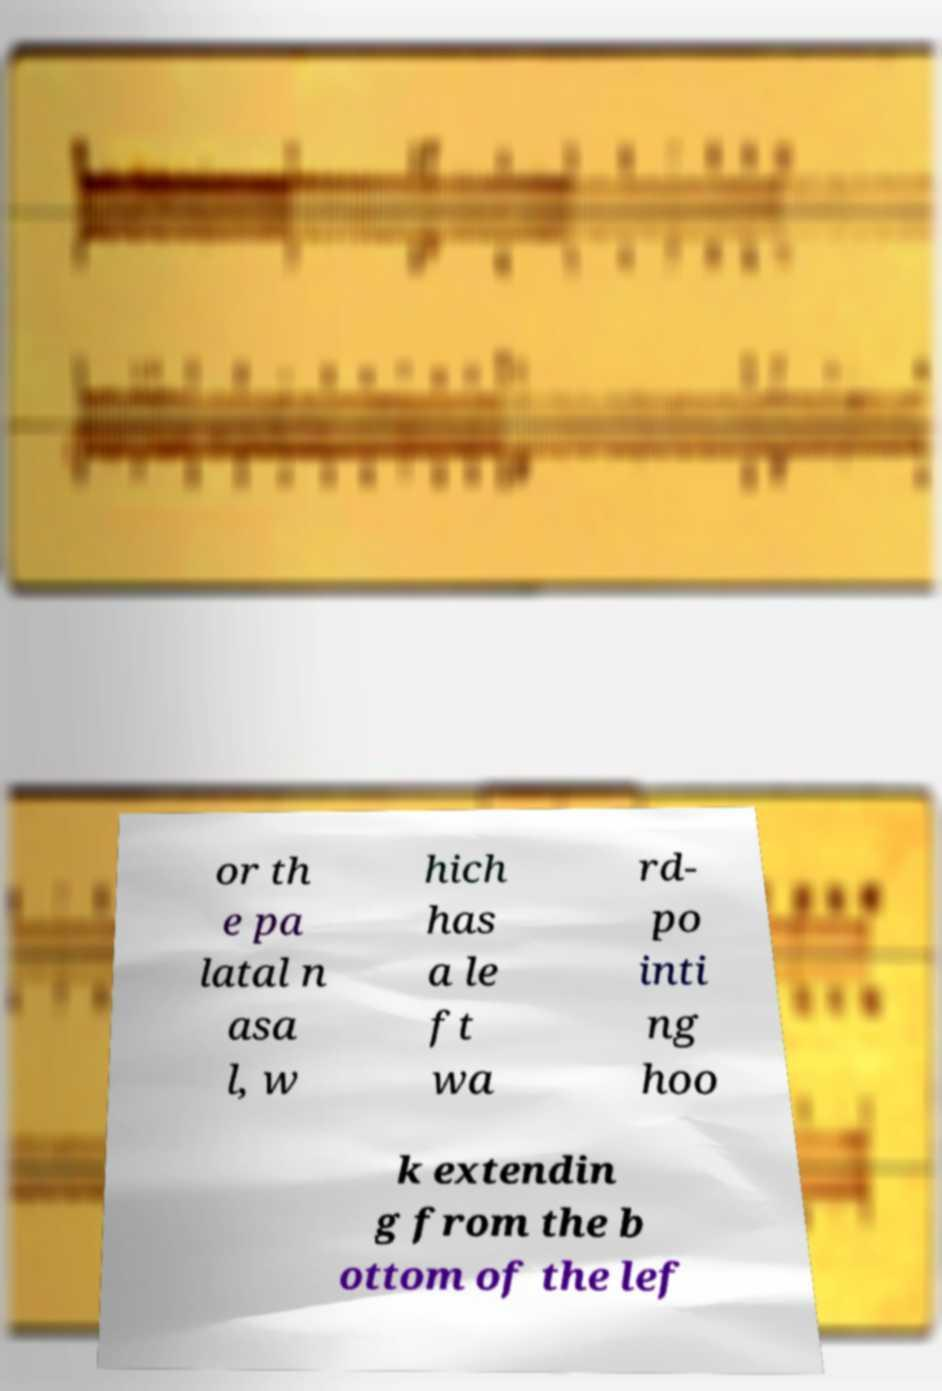Could you assist in decoding the text presented in this image and type it out clearly? or th e pa latal n asa l, w hich has a le ft wa rd- po inti ng hoo k extendin g from the b ottom of the lef 